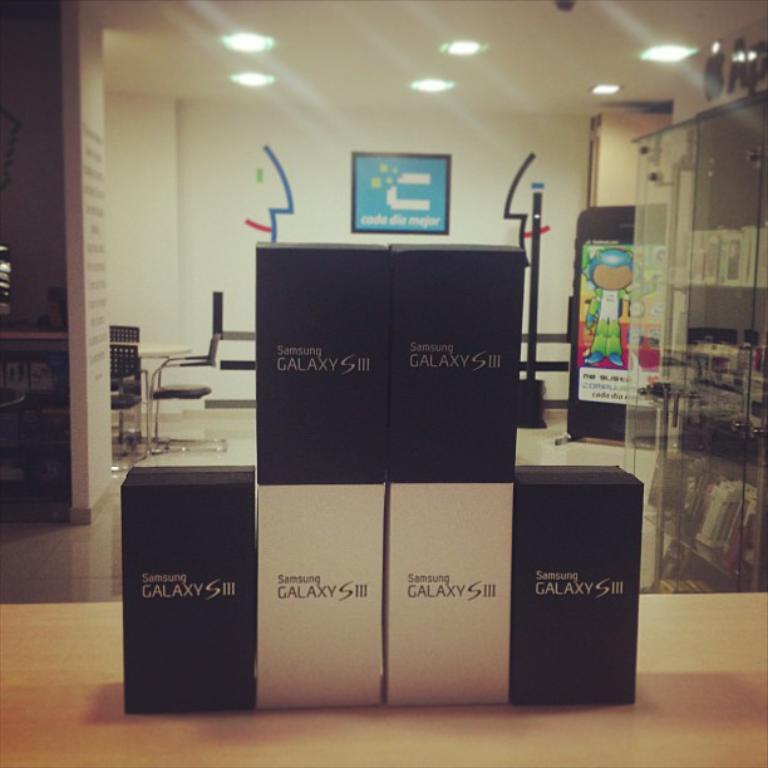What is the product caleld?
Your response must be concise. Galaxy s iii. 